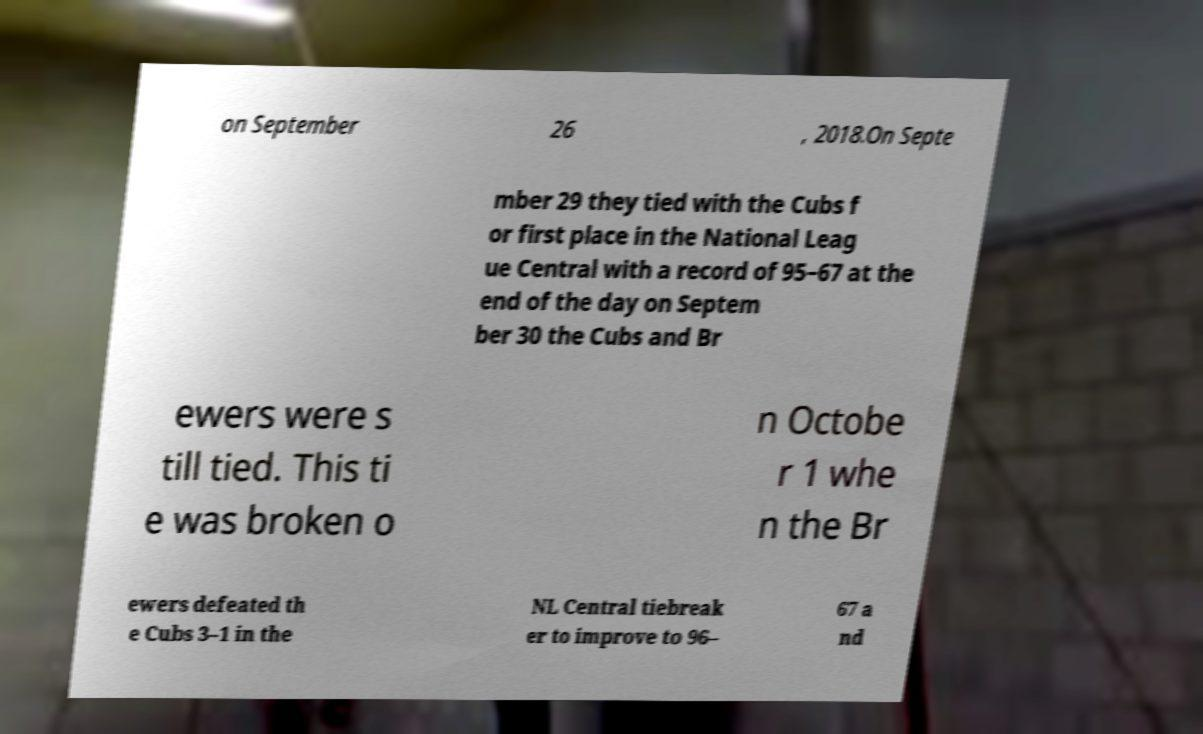There's text embedded in this image that I need extracted. Can you transcribe it verbatim? on September 26 , 2018.On Septe mber 29 they tied with the Cubs f or first place in the National Leag ue Central with a record of 95–67 at the end of the day on Septem ber 30 the Cubs and Br ewers were s till tied. This ti e was broken o n Octobe r 1 whe n the Br ewers defeated th e Cubs 3–1 in the NL Central tiebreak er to improve to 96– 67 a nd 